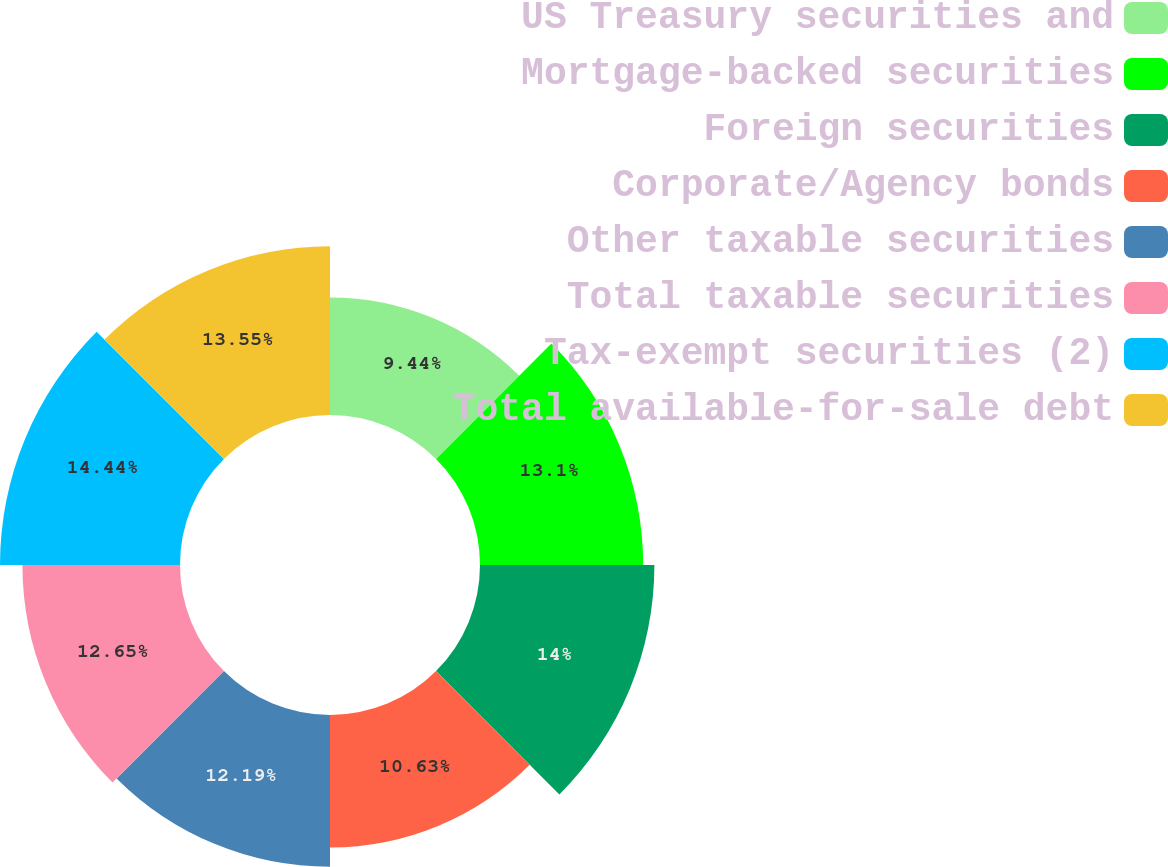Convert chart. <chart><loc_0><loc_0><loc_500><loc_500><pie_chart><fcel>US Treasury securities and<fcel>Mortgage-backed securities<fcel>Foreign securities<fcel>Corporate/Agency bonds<fcel>Other taxable securities<fcel>Total taxable securities<fcel>Tax-exempt securities (2)<fcel>Total available-for-sale debt<nl><fcel>9.44%<fcel>13.1%<fcel>14.0%<fcel>10.63%<fcel>12.19%<fcel>12.65%<fcel>14.45%<fcel>13.55%<nl></chart> 